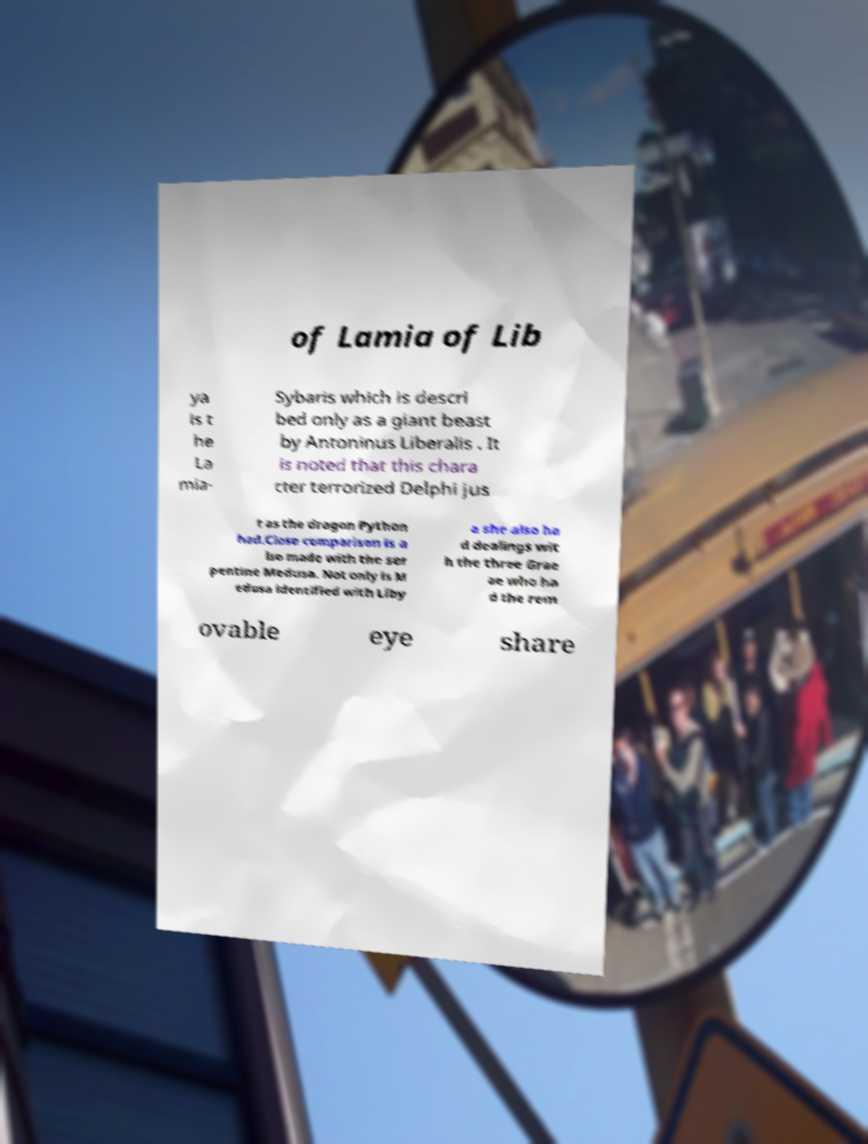Can you read and provide the text displayed in the image?This photo seems to have some interesting text. Can you extract and type it out for me? of Lamia of Lib ya is t he La mia- Sybaris which is descri bed only as a giant beast by Antoninus Liberalis . It is noted that this chara cter terrorized Delphi jus t as the dragon Python had.Close comparison is a lso made with the ser pentine Medusa. Not only is M edusa identified with Liby a she also ha d dealings wit h the three Grae ae who ha d the rem ovable eye share 